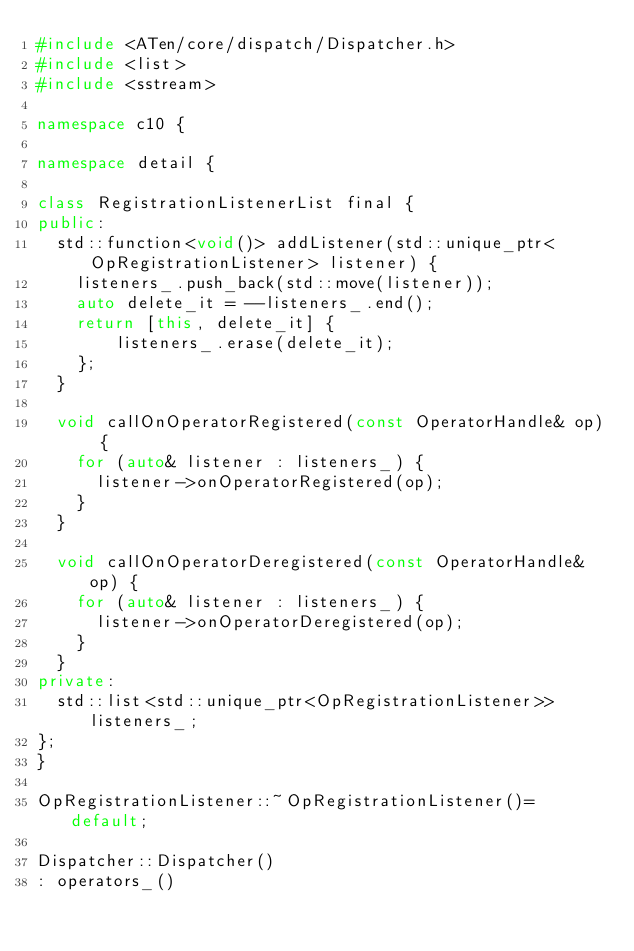<code> <loc_0><loc_0><loc_500><loc_500><_C++_>#include <ATen/core/dispatch/Dispatcher.h>
#include <list>
#include <sstream>

namespace c10 {

namespace detail {

class RegistrationListenerList final {
public:
  std::function<void()> addListener(std::unique_ptr<OpRegistrationListener> listener) {
    listeners_.push_back(std::move(listener));
    auto delete_it = --listeners_.end();
    return [this, delete_it] {
        listeners_.erase(delete_it);
    };
  }

  void callOnOperatorRegistered(const OperatorHandle& op) {
    for (auto& listener : listeners_) {
      listener->onOperatorRegistered(op);
    }
  }

  void callOnOperatorDeregistered(const OperatorHandle& op) {
    for (auto& listener : listeners_) {
      listener->onOperatorDeregistered(op);
    }
  }
private:
  std::list<std::unique_ptr<OpRegistrationListener>> listeners_;
};
}

OpRegistrationListener::~OpRegistrationListener()= default;

Dispatcher::Dispatcher()
: operators_()</code> 